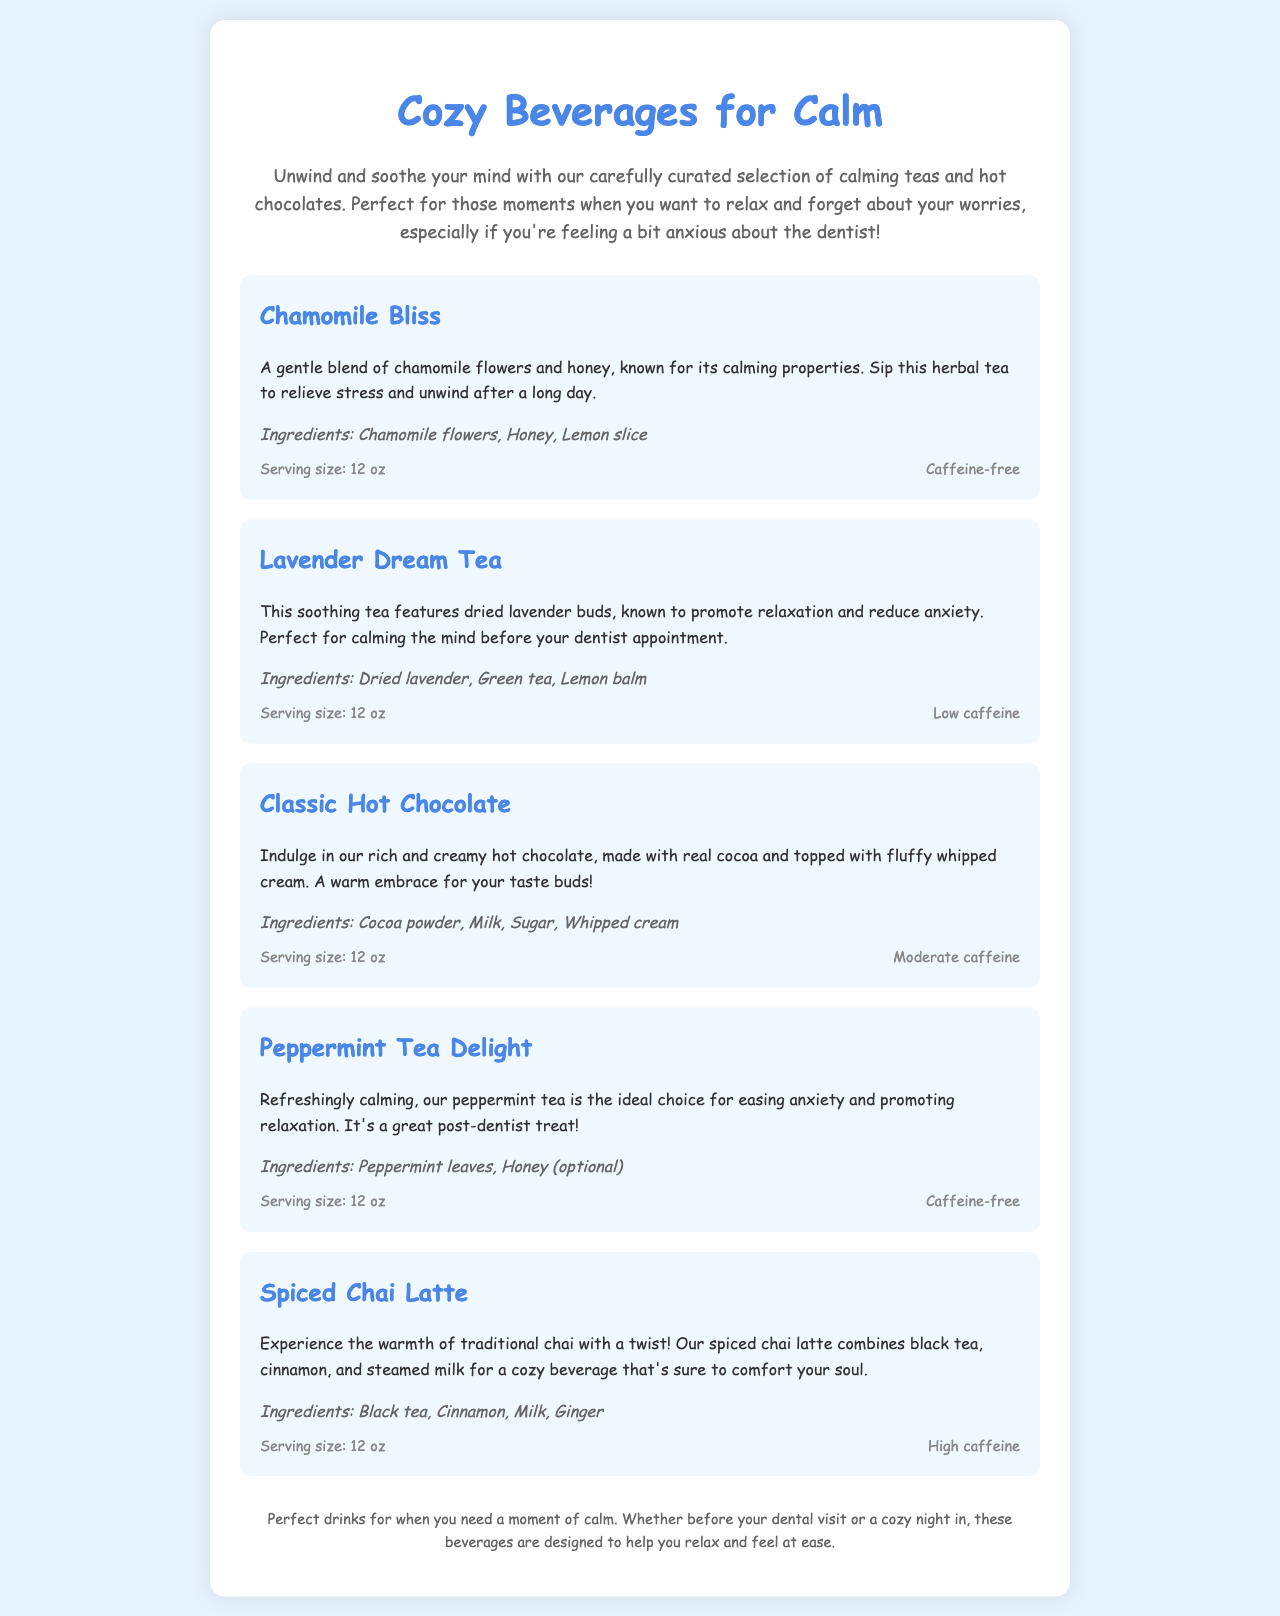What is the title of the menu? The title of the menu is the first heading which indicates the theme of the offerings.
Answer: Cozy Beverages for Calm How many beverage options are listed? The number of beverage options can be counted in the document.
Answer: Five What is the ingredient in Chamomile Bliss that provides sweetness? The ingredient known for providing sweetness in Chamomile Bliss is explicitly mentioned.
Answer: Honey Which beverage is caffeine-free? This question requires looking for options without caffeine noted in their descriptions.
Answer: Chamomile Bliss and Peppermint Tea Delight What is the serving size of the drinks? The serving size is mentioned consistently for all beverages, influencing the portion given.
Answer: 12 oz What is the main benefit of Lavender Dream Tea? The benefit of Lavender Dream Tea is succinctly described in the document.
Answer: Promote relaxation and reduce anxiety Which beverage combines black tea and cinnamon? This beverage is specifically identified by its unique ingredients.
Answer: Spiced Chai Latte What type of drink is Classic Hot Chocolate described as? The description of Classic Hot Chocolate indicates its comforting nature.
Answer: Rich and creamy hot chocolate 